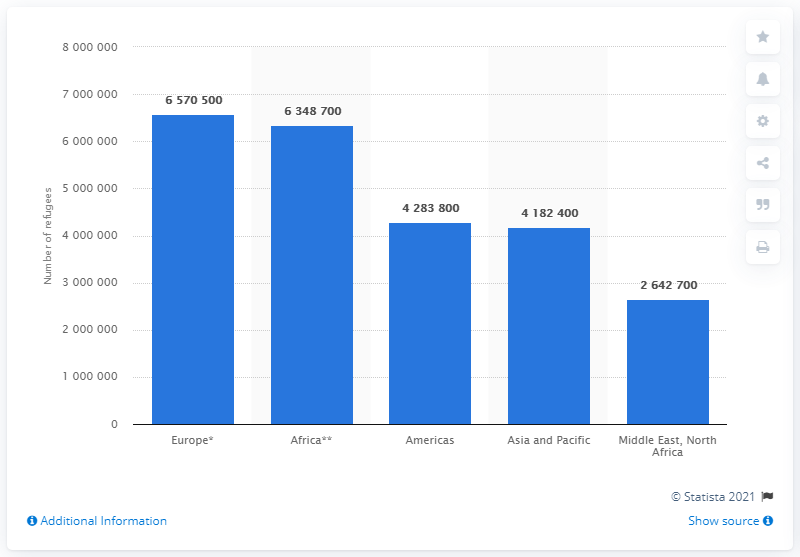Highlight a few significant elements in this photo. According to the United Nations High Commissioner for Refugees (UNHCR), at the end of 2019, there were approximately 428,380 refugees living in the Americas region. 